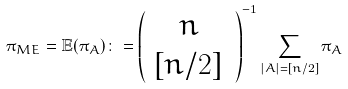Convert formula to latex. <formula><loc_0><loc_0><loc_500><loc_500>\pi _ { M E } = \mathbb { E } ( \pi _ { A } ) \colon = \left ( \begin{array} { c } n \\ { [ n / 2 ] } \end{array} \, \right ) ^ { - 1 } \sum _ { | A | = [ n / 2 ] } \pi _ { A }</formula> 